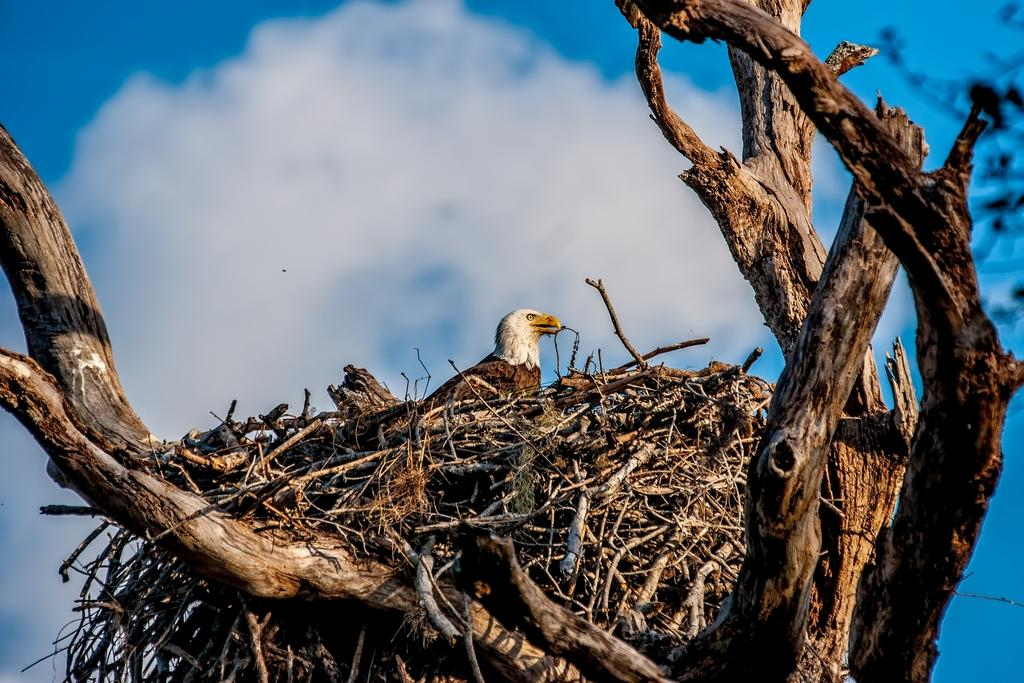What type of bird is in the picture? There is an eagle in the picture. Can you describe the color of the eagle? The eagle is brown and white in color. Where is the eagle located in the image? The eagle is sitting in a nest. What is the nest placed on? The nest is placed on dry tree branches. What can be seen in the background of the image? The sky is visible in the background of the image, and white clouds are present. How many brothers are present in the image? There are no brothers present in the image; it features an eagle sitting in a nest. What type of scene is depicted in the image? The image depicts a natural scene with an eagle in a nest on dry tree branches, and the sky with white clouds in the background. 